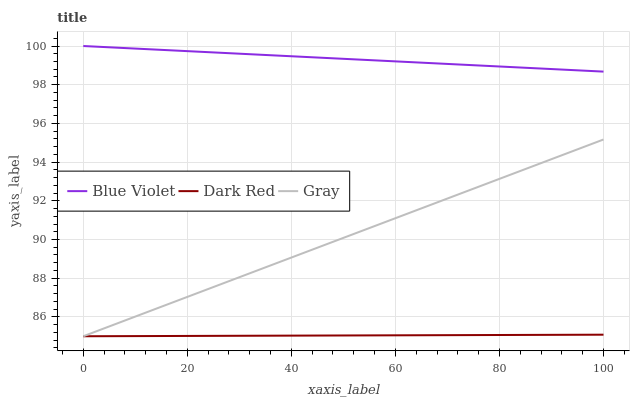Does Dark Red have the minimum area under the curve?
Answer yes or no. Yes. Does Blue Violet have the maximum area under the curve?
Answer yes or no. Yes. Does Gray have the minimum area under the curve?
Answer yes or no. No. Does Gray have the maximum area under the curve?
Answer yes or no. No. Is Dark Red the smoothest?
Answer yes or no. Yes. Is Blue Violet the roughest?
Answer yes or no. Yes. Is Gray the smoothest?
Answer yes or no. No. Is Gray the roughest?
Answer yes or no. No. Does Dark Red have the lowest value?
Answer yes or no. Yes. Does Blue Violet have the lowest value?
Answer yes or no. No. Does Blue Violet have the highest value?
Answer yes or no. Yes. Does Gray have the highest value?
Answer yes or no. No. Is Gray less than Blue Violet?
Answer yes or no. Yes. Is Blue Violet greater than Dark Red?
Answer yes or no. Yes. Does Gray intersect Dark Red?
Answer yes or no. Yes. Is Gray less than Dark Red?
Answer yes or no. No. Is Gray greater than Dark Red?
Answer yes or no. No. Does Gray intersect Blue Violet?
Answer yes or no. No. 